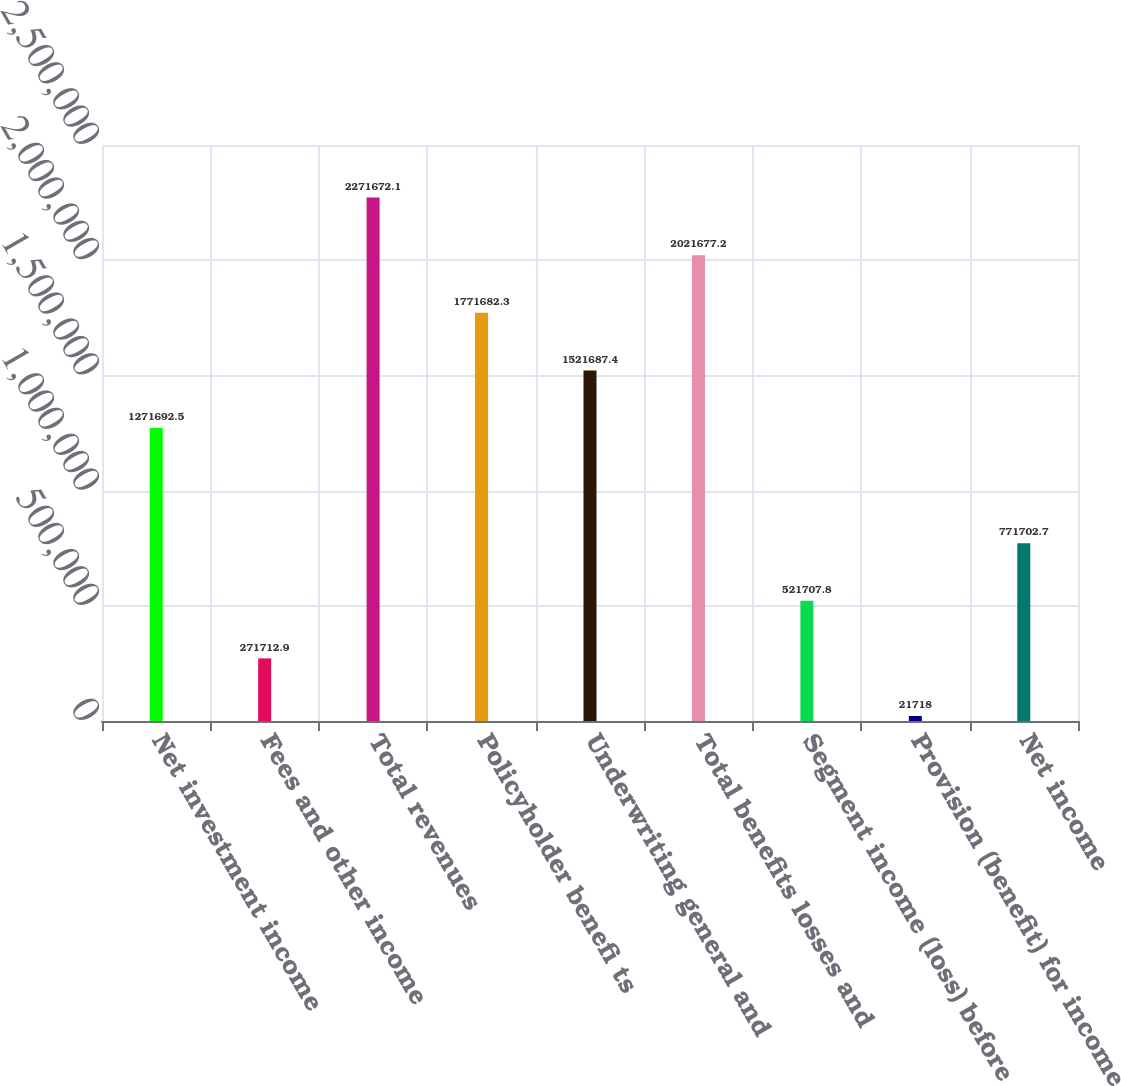Convert chart. <chart><loc_0><loc_0><loc_500><loc_500><bar_chart><fcel>Net investment income<fcel>Fees and other income<fcel>Total revenues<fcel>Policyholder benefi ts<fcel>Underwriting general and<fcel>Total benefits losses and<fcel>Segment income (loss) before<fcel>Provision (benefit) for income<fcel>Net income<nl><fcel>1.27169e+06<fcel>271713<fcel>2.27167e+06<fcel>1.77168e+06<fcel>1.52169e+06<fcel>2.02168e+06<fcel>521708<fcel>21718<fcel>771703<nl></chart> 